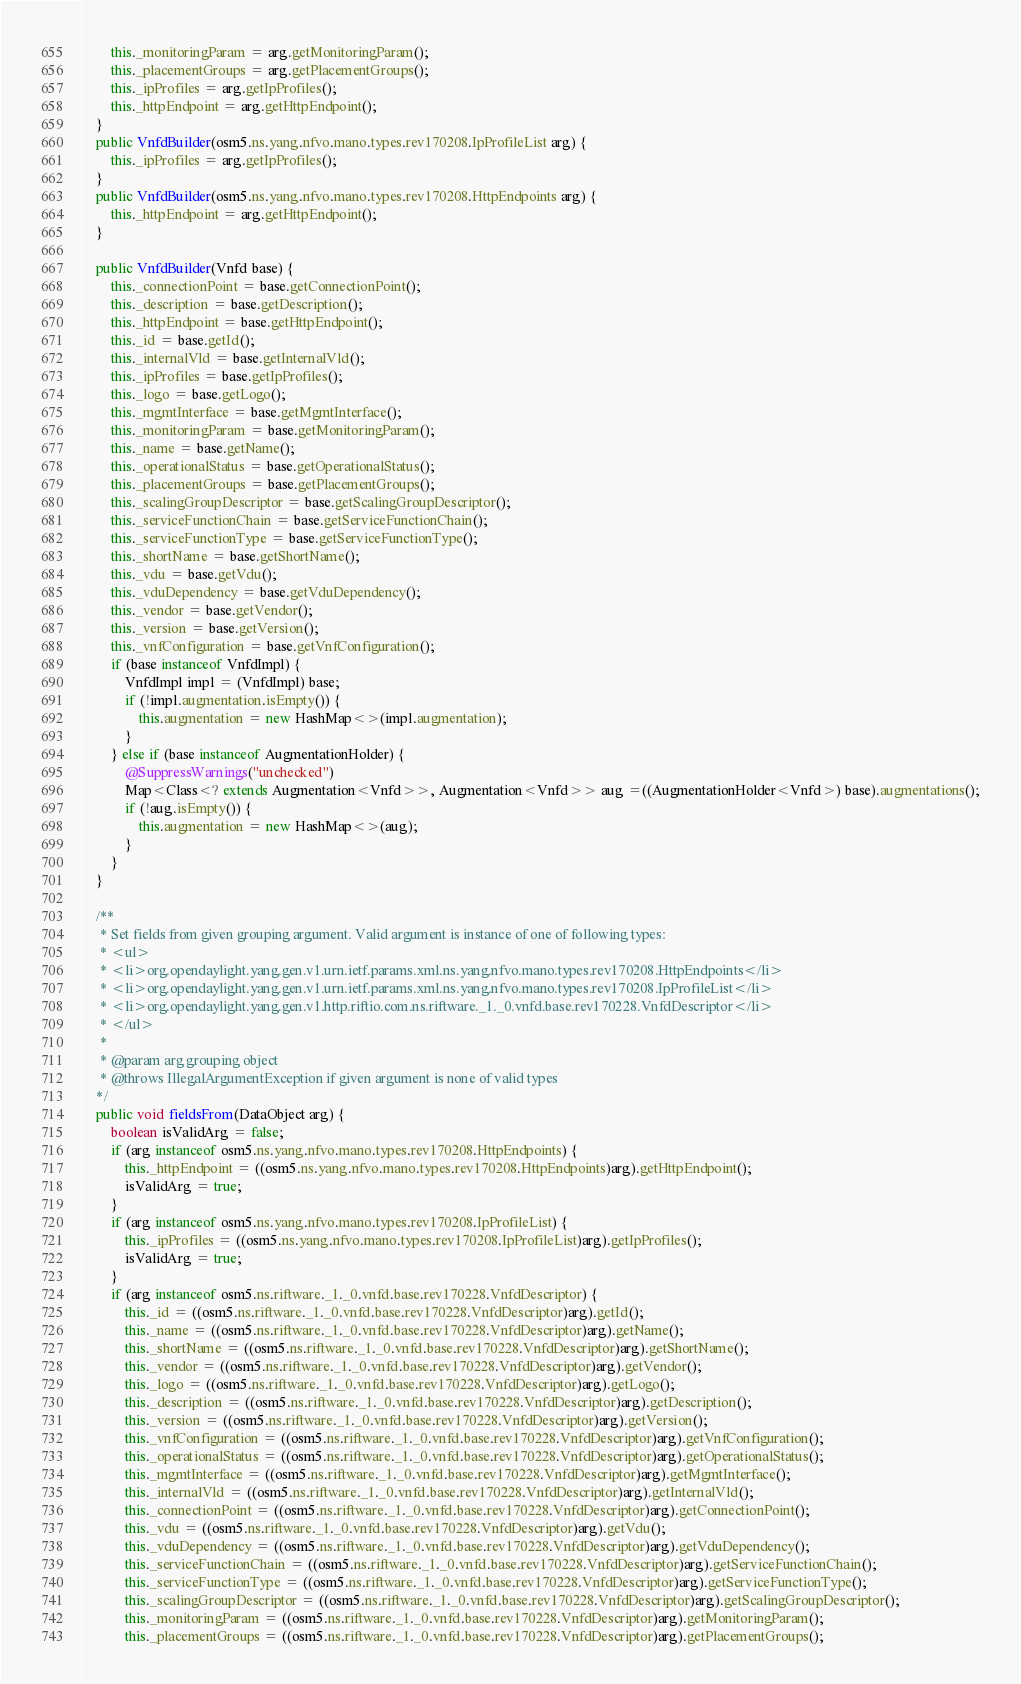<code> <loc_0><loc_0><loc_500><loc_500><_Java_>        this._monitoringParam = arg.getMonitoringParam();
        this._placementGroups = arg.getPlacementGroups();
        this._ipProfiles = arg.getIpProfiles();
        this._httpEndpoint = arg.getHttpEndpoint();
    }
    public VnfdBuilder(osm5.ns.yang.nfvo.mano.types.rev170208.IpProfileList arg) {
        this._ipProfiles = arg.getIpProfiles();
    }
    public VnfdBuilder(osm5.ns.yang.nfvo.mano.types.rev170208.HttpEndpoints arg) {
        this._httpEndpoint = arg.getHttpEndpoint();
    }

    public VnfdBuilder(Vnfd base) {
        this._connectionPoint = base.getConnectionPoint();
        this._description = base.getDescription();
        this._httpEndpoint = base.getHttpEndpoint();
        this._id = base.getId();
        this._internalVld = base.getInternalVld();
        this._ipProfiles = base.getIpProfiles();
        this._logo = base.getLogo();
        this._mgmtInterface = base.getMgmtInterface();
        this._monitoringParam = base.getMonitoringParam();
        this._name = base.getName();
        this._operationalStatus = base.getOperationalStatus();
        this._placementGroups = base.getPlacementGroups();
        this._scalingGroupDescriptor = base.getScalingGroupDescriptor();
        this._serviceFunctionChain = base.getServiceFunctionChain();
        this._serviceFunctionType = base.getServiceFunctionType();
        this._shortName = base.getShortName();
        this._vdu = base.getVdu();
        this._vduDependency = base.getVduDependency();
        this._vendor = base.getVendor();
        this._version = base.getVersion();
        this._vnfConfiguration = base.getVnfConfiguration();
        if (base instanceof VnfdImpl) {
            VnfdImpl impl = (VnfdImpl) base;
            if (!impl.augmentation.isEmpty()) {
                this.augmentation = new HashMap<>(impl.augmentation);
            }
        } else if (base instanceof AugmentationHolder) {
            @SuppressWarnings("unchecked")
            Map<Class<? extends Augmentation<Vnfd>>, Augmentation<Vnfd>> aug =((AugmentationHolder<Vnfd>) base).augmentations();
            if (!aug.isEmpty()) {
                this.augmentation = new HashMap<>(aug);
            }
        }
    }

    /**
     * Set fields from given grouping argument. Valid argument is instance of one of following types:
     * <ul>
     * <li>org.opendaylight.yang.gen.v1.urn.ietf.params.xml.ns.yang.nfvo.mano.types.rev170208.HttpEndpoints</li>
     * <li>org.opendaylight.yang.gen.v1.urn.ietf.params.xml.ns.yang.nfvo.mano.types.rev170208.IpProfileList</li>
     * <li>org.opendaylight.yang.gen.v1.http.riftio.com.ns.riftware._1._0.vnfd.base.rev170228.VnfdDescriptor</li>
     * </ul>
     *
     * @param arg grouping object
     * @throws IllegalArgumentException if given argument is none of valid types
    */
    public void fieldsFrom(DataObject arg) {
        boolean isValidArg = false;
        if (arg instanceof osm5.ns.yang.nfvo.mano.types.rev170208.HttpEndpoints) {
            this._httpEndpoint = ((osm5.ns.yang.nfvo.mano.types.rev170208.HttpEndpoints)arg).getHttpEndpoint();
            isValidArg = true;
        }
        if (arg instanceof osm5.ns.yang.nfvo.mano.types.rev170208.IpProfileList) {
            this._ipProfiles = ((osm5.ns.yang.nfvo.mano.types.rev170208.IpProfileList)arg).getIpProfiles();
            isValidArg = true;
        }
        if (arg instanceof osm5.ns.riftware._1._0.vnfd.base.rev170228.VnfdDescriptor) {
            this._id = ((osm5.ns.riftware._1._0.vnfd.base.rev170228.VnfdDescriptor)arg).getId();
            this._name = ((osm5.ns.riftware._1._0.vnfd.base.rev170228.VnfdDescriptor)arg).getName();
            this._shortName = ((osm5.ns.riftware._1._0.vnfd.base.rev170228.VnfdDescriptor)arg).getShortName();
            this._vendor = ((osm5.ns.riftware._1._0.vnfd.base.rev170228.VnfdDescriptor)arg).getVendor();
            this._logo = ((osm5.ns.riftware._1._0.vnfd.base.rev170228.VnfdDescriptor)arg).getLogo();
            this._description = ((osm5.ns.riftware._1._0.vnfd.base.rev170228.VnfdDescriptor)arg).getDescription();
            this._version = ((osm5.ns.riftware._1._0.vnfd.base.rev170228.VnfdDescriptor)arg).getVersion();
            this._vnfConfiguration = ((osm5.ns.riftware._1._0.vnfd.base.rev170228.VnfdDescriptor)arg).getVnfConfiguration();
            this._operationalStatus = ((osm5.ns.riftware._1._0.vnfd.base.rev170228.VnfdDescriptor)arg).getOperationalStatus();
            this._mgmtInterface = ((osm5.ns.riftware._1._0.vnfd.base.rev170228.VnfdDescriptor)arg).getMgmtInterface();
            this._internalVld = ((osm5.ns.riftware._1._0.vnfd.base.rev170228.VnfdDescriptor)arg).getInternalVld();
            this._connectionPoint = ((osm5.ns.riftware._1._0.vnfd.base.rev170228.VnfdDescriptor)arg).getConnectionPoint();
            this._vdu = ((osm5.ns.riftware._1._0.vnfd.base.rev170228.VnfdDescriptor)arg).getVdu();
            this._vduDependency = ((osm5.ns.riftware._1._0.vnfd.base.rev170228.VnfdDescriptor)arg).getVduDependency();
            this._serviceFunctionChain = ((osm5.ns.riftware._1._0.vnfd.base.rev170228.VnfdDescriptor)arg).getServiceFunctionChain();
            this._serviceFunctionType = ((osm5.ns.riftware._1._0.vnfd.base.rev170228.VnfdDescriptor)arg).getServiceFunctionType();
            this._scalingGroupDescriptor = ((osm5.ns.riftware._1._0.vnfd.base.rev170228.VnfdDescriptor)arg).getScalingGroupDescriptor();
            this._monitoringParam = ((osm5.ns.riftware._1._0.vnfd.base.rev170228.VnfdDescriptor)arg).getMonitoringParam();
            this._placementGroups = ((osm5.ns.riftware._1._0.vnfd.base.rev170228.VnfdDescriptor)arg).getPlacementGroups();</code> 